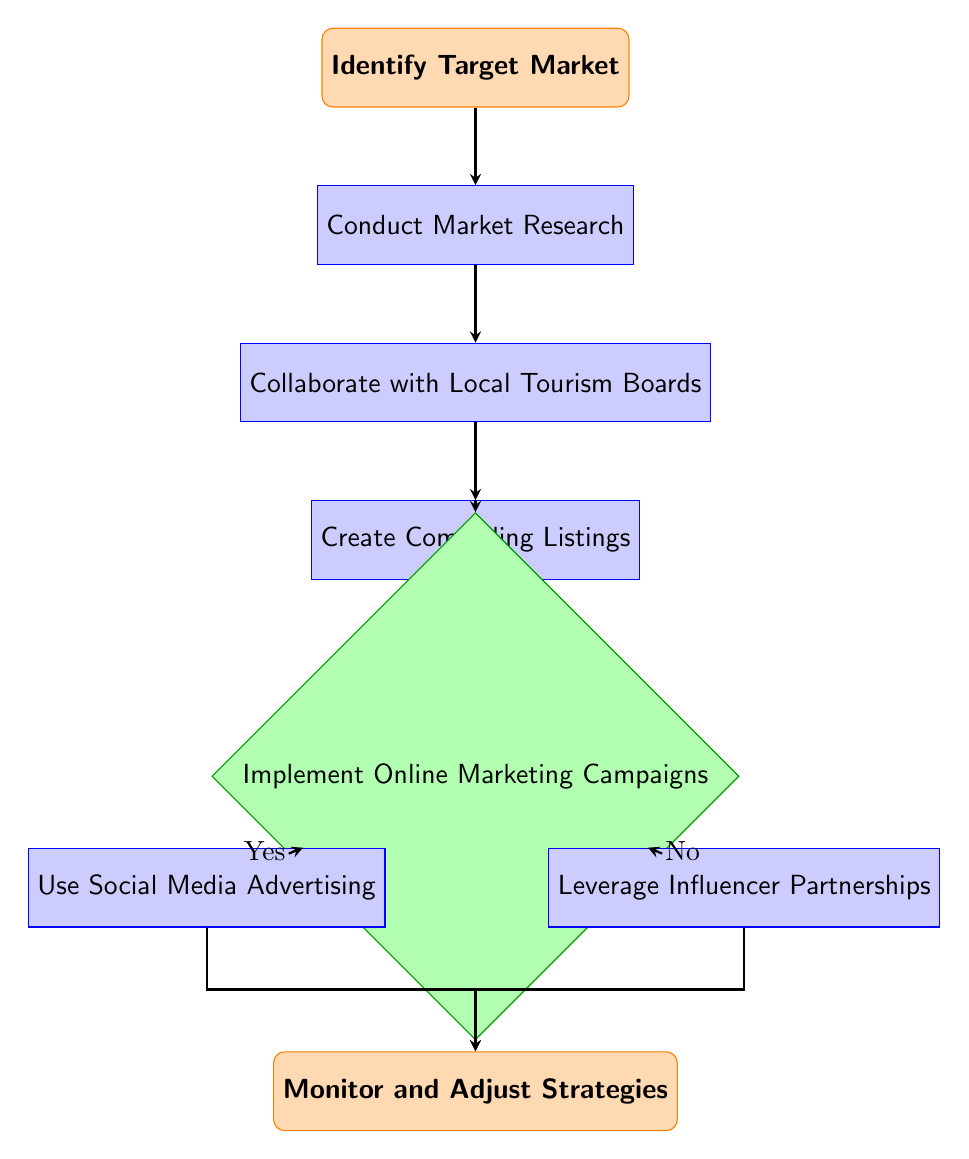What is the first step in the marketing strategy? The first step in the diagram is to "Identify Target Market," which is the starting point of the flow chart.
Answer: Identify Target Market How many total nodes are in this diagram? By counting the nodes listed, there are a total of eight nodes present in the flow chart.
Answer: Eight What process follows after conducting market research? After "Conduct Market Research," the next step is "Collaborate with Local Tourism Boards," which is directly positioned below it in the flow chart.
Answer: Collaborate with Local Tourism Boards What are the two options after implementing online marketing campaigns? The options following "Implement Online Marketing Campaigns" are "Use Social Media Advertising" if the answer is Yes, or "Leverage Influencer Partnerships" if the answer is No.
Answer: Use Social Media Advertising and Leverage Influencer Partnerships What is the final step in the marketing strategy? The final step in the flow chart is "Monitor and Adjust Strategies," which concludes the marketing strategy process.
Answer: Monitor and Adjust Strategies If the answer is "No" to implementing online marketing campaigns, what is the next action? If the answer is "No," the next action taken is "Leverage Influencer Partnerships," which is the subsequent process linked to the decision node.
Answer: Leverage Influencer Partnerships Which node represents a decision in the flowchart? The node labeled "Implement Online Marketing Campaigns" is represented as a decision in the flowchart, indicated by its diamond shape.
Answer: Implement Online Marketing Campaigns How does social media advertising connect to the overall strategy? "Use Social Media Advertising" directly follows from the decision of implementing online marketing campaigns when the answer is Yes and connects to monitoring strategies afterward.
Answer: It connects through the Yes pathway 